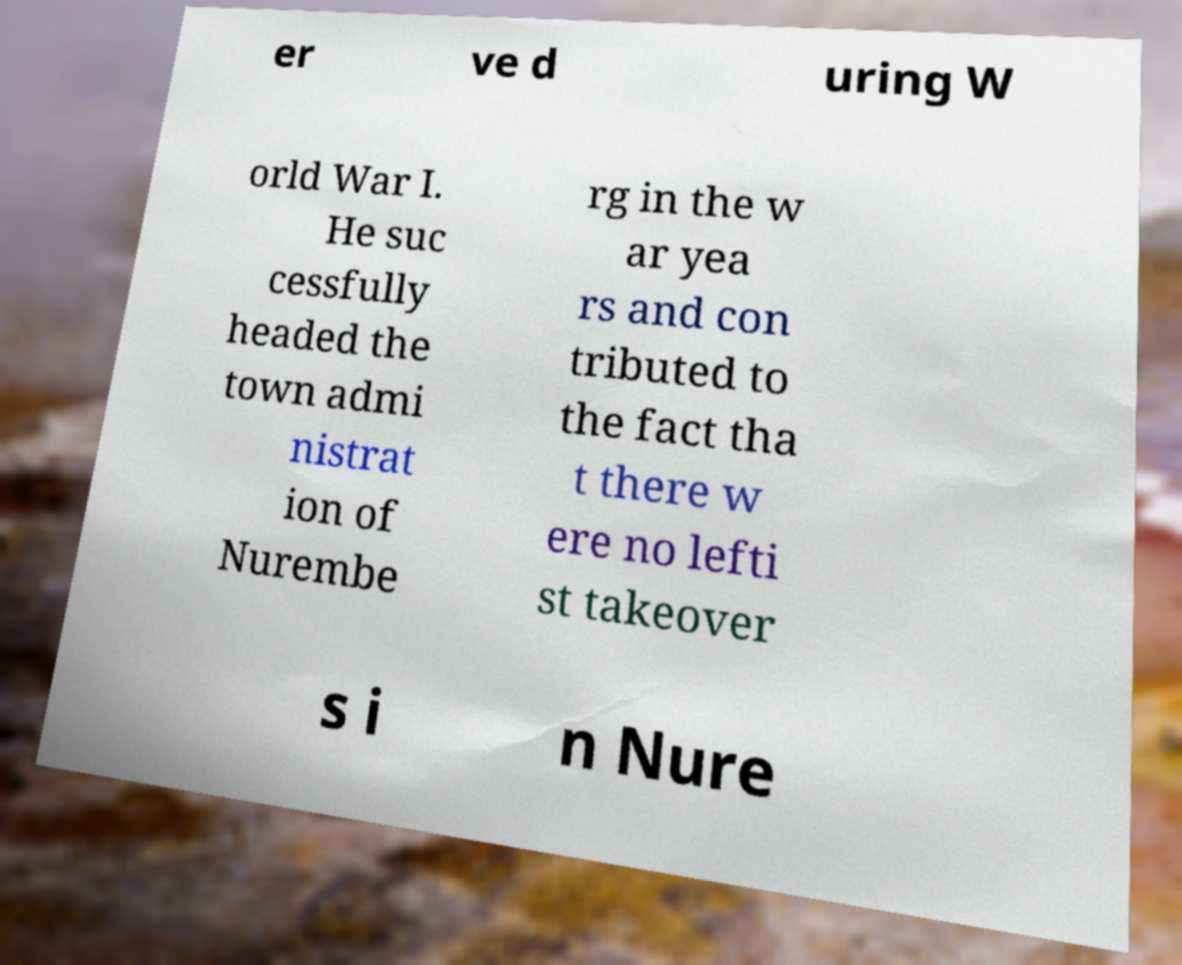What messages or text are displayed in this image? I need them in a readable, typed format. er ve d uring W orld War I. He suc cessfully headed the town admi nistrat ion of Nurembe rg in the w ar yea rs and con tributed to the fact tha t there w ere no lefti st takeover s i n Nure 